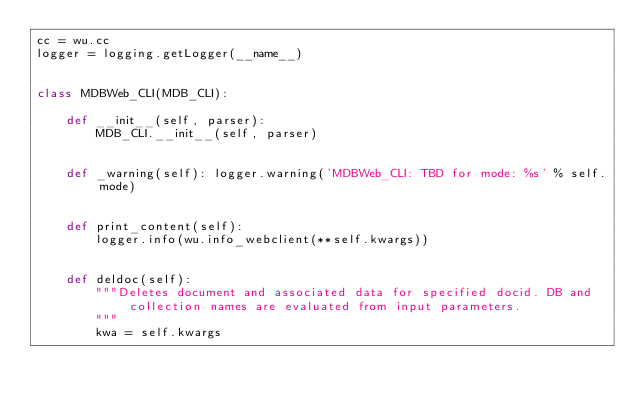Convert code to text. <code><loc_0><loc_0><loc_500><loc_500><_Python_>cc = wu.cc
logger = logging.getLogger(__name__)


class MDBWeb_CLI(MDB_CLI):

    def __init__(self, parser):
        MDB_CLI.__init__(self, parser)


    def _warning(self): logger.warning('MDBWeb_CLI: TBD for mode: %s' % self.mode)


    def print_content(self):
        logger.info(wu.info_webclient(**self.kwargs))


    def deldoc(self):
        """Deletes document and associated data for specified docid. DB and collection names are evaluated from input parameters.
        """
        kwa = self.kwargs</code> 